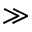<formula> <loc_0><loc_0><loc_500><loc_500>\gg</formula> 